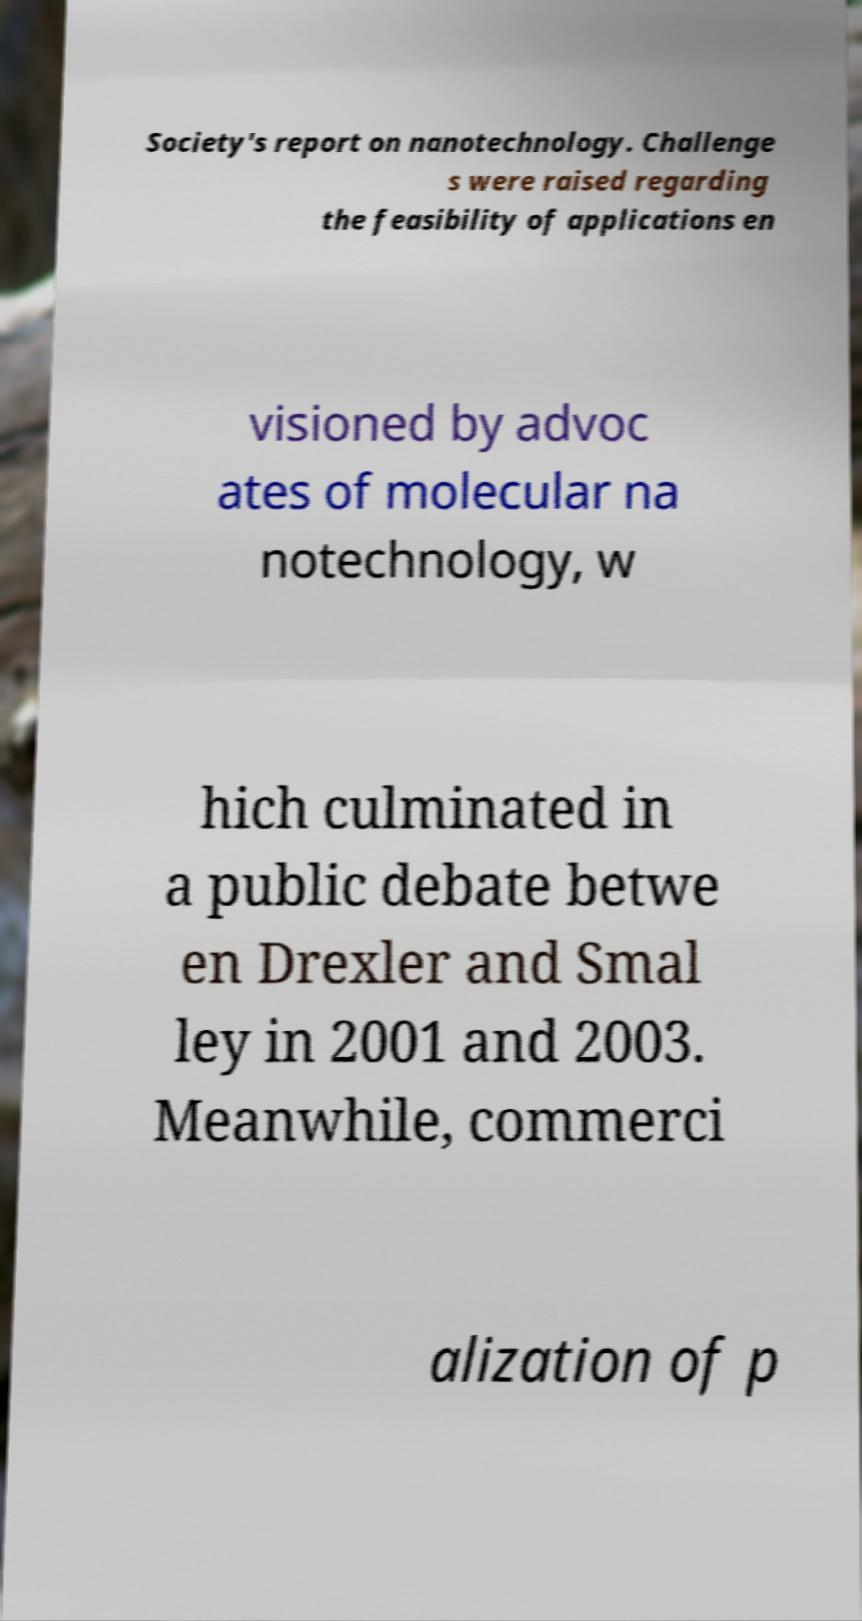Can you read and provide the text displayed in the image?This photo seems to have some interesting text. Can you extract and type it out for me? Society's report on nanotechnology. Challenge s were raised regarding the feasibility of applications en visioned by advoc ates of molecular na notechnology, w hich culminated in a public debate betwe en Drexler and Smal ley in 2001 and 2003. Meanwhile, commerci alization of p 